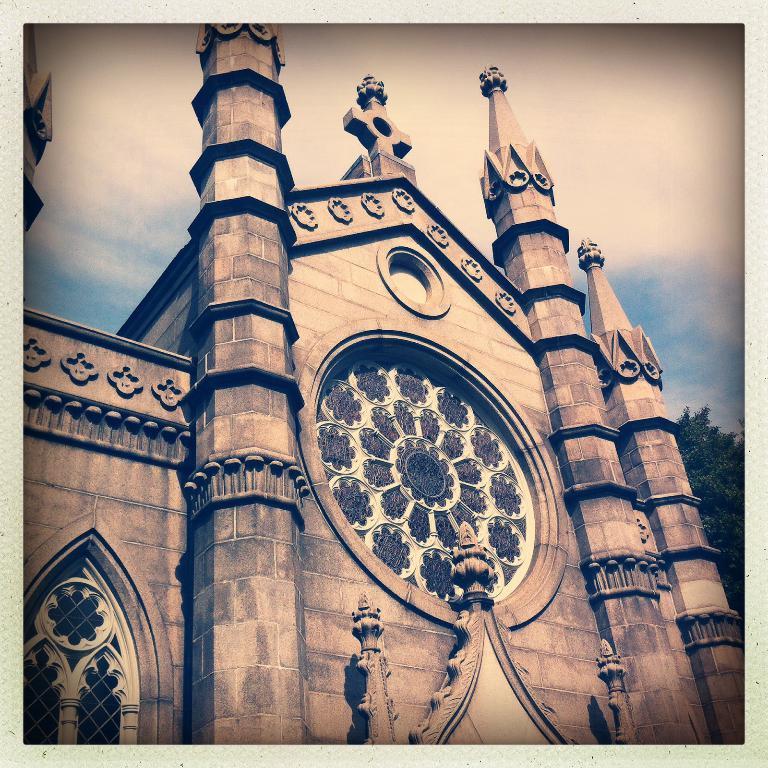In one or two sentences, can you explain what this image depicts? In this picture we can see building and green leaves. In the background of the image we can see sky with clouds. 